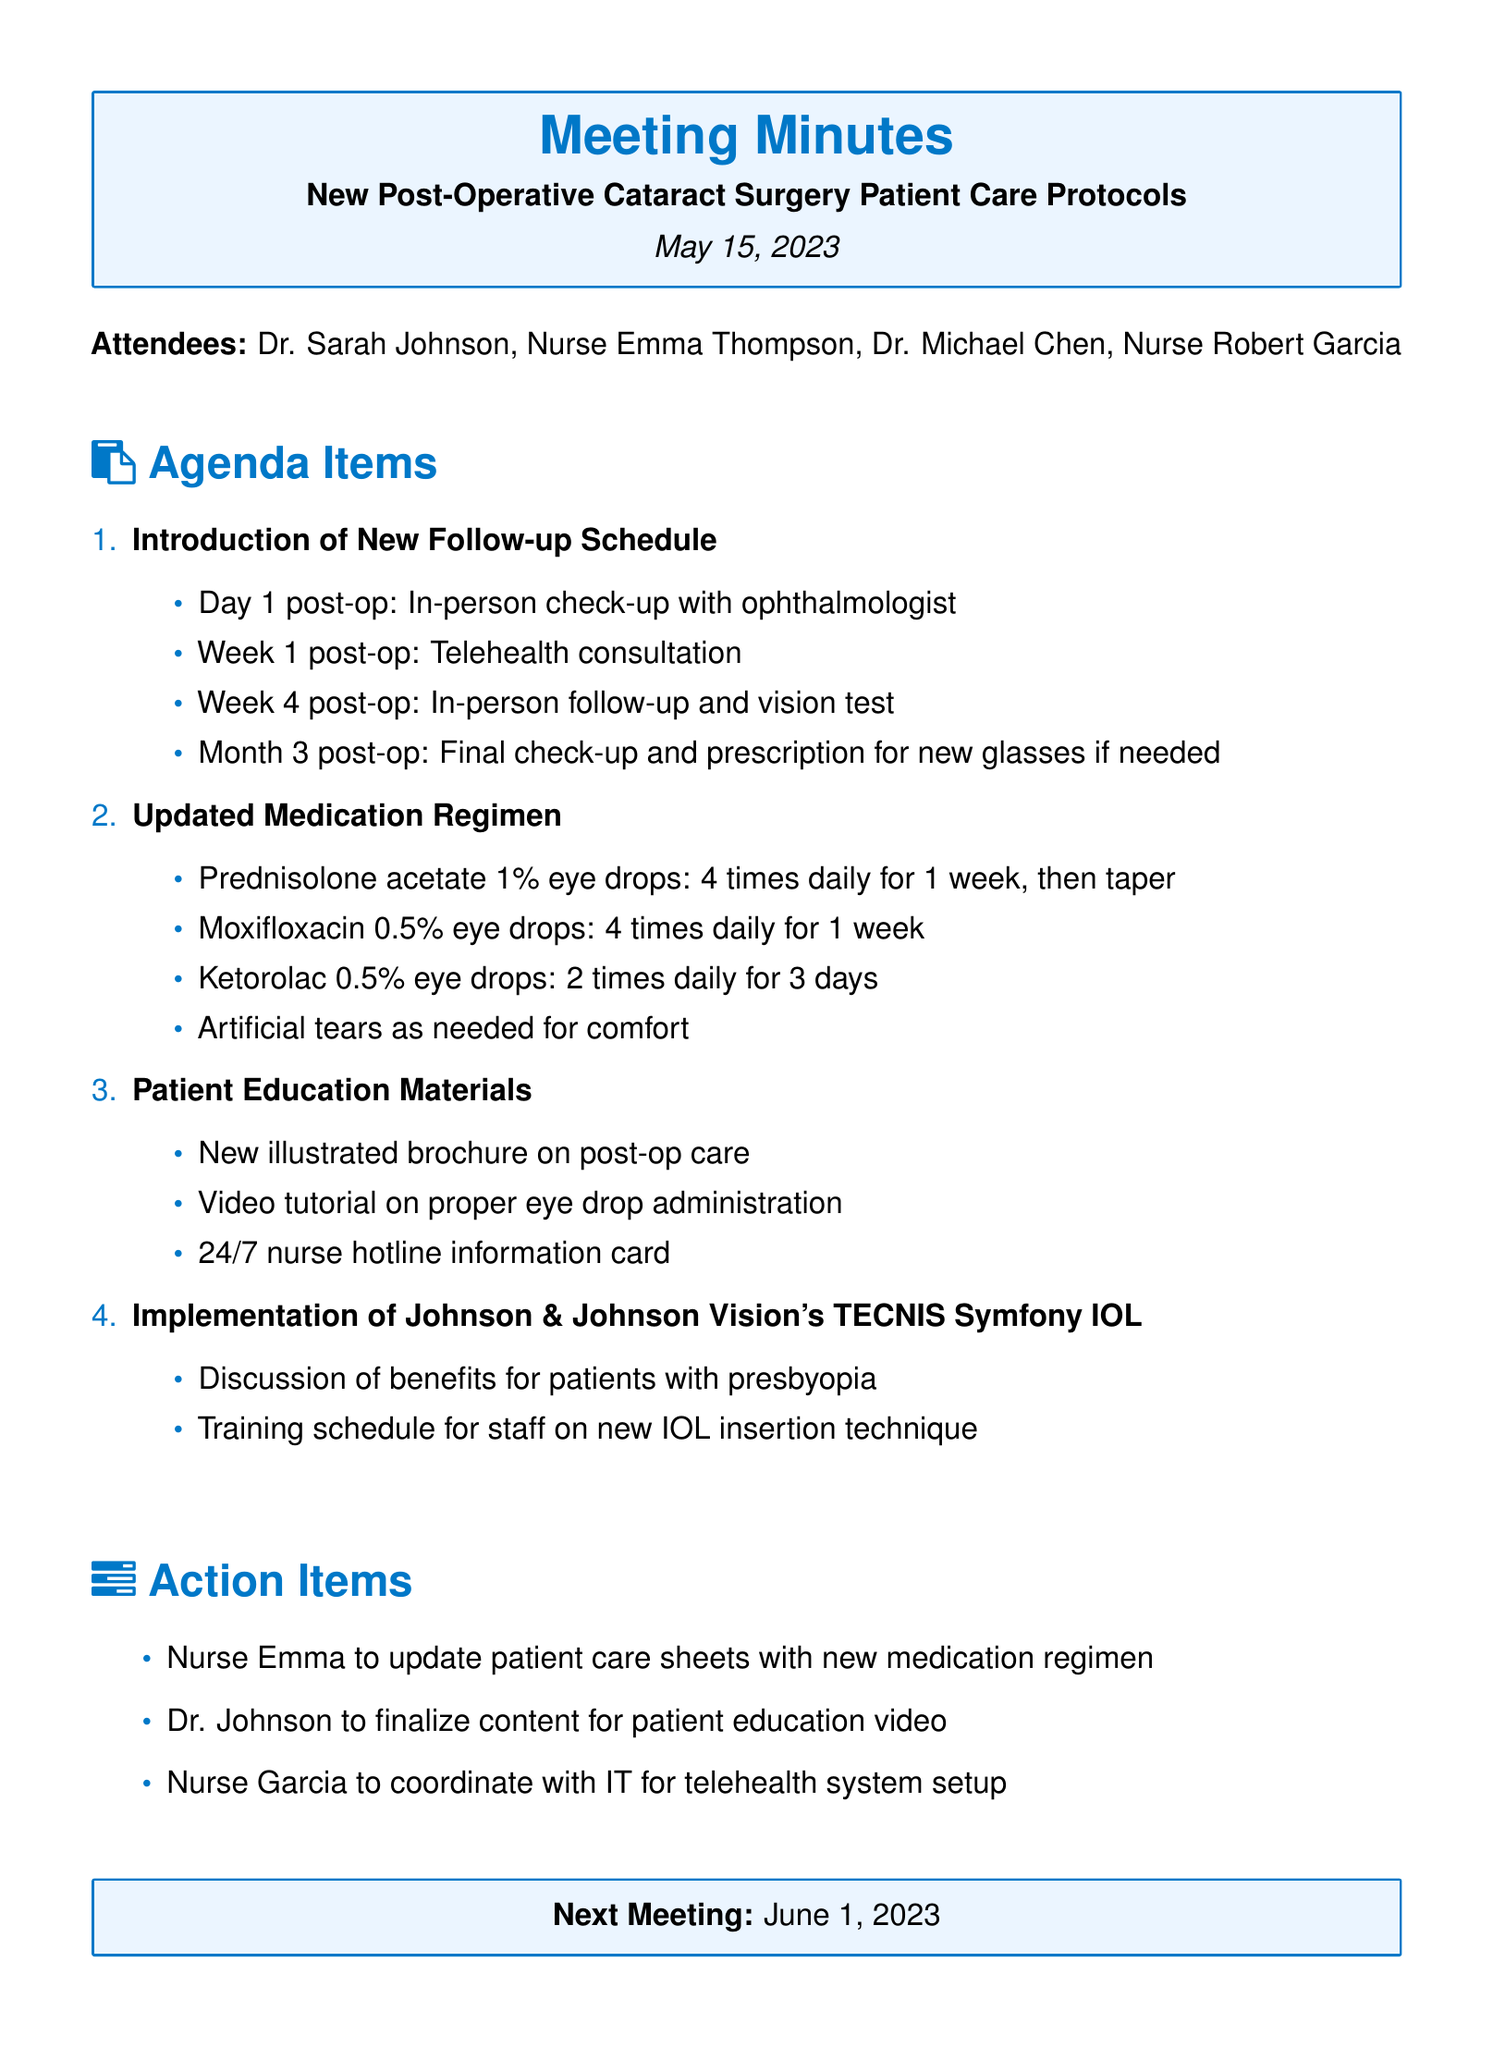What is the meeting title? The meeting title is stated at the beginning of the document.
Answer: New Post-Operative Cataract Surgery Patient Care Protocols What date was the meeting held? The date is listed just below the meeting title.
Answer: May 15, 2023 Who is the lead ophthalmologist? The lead ophthalmologist is mentioned in the list of attendees.
Answer: Dr. Sarah Johnson What is the follow-up schedule for Week 1 post-op? The follow-up schedule details are listed under the agenda items.
Answer: Telehealth consultation How often should Prednisolone acetate 1% eye drops be administered? The updated medication regimen specifies the frequency of eye drop administration.
Answer: 4 times daily for 1 week, then taper What is one of the new patient education materials? The patient education materials section lists several new resources.
Answer: New illustrated brochure on post-op care What is the next meeting date? The date of the next meeting is noted at the end of the document.
Answer: June 1, 2023 Who is responsible for updating patient care sheets? The action items detail responsibilities assigned to attendees.
Answer: Nurse Emma What is one benefit discussed regarding the TECNIS Symfony IOL? The agenda item regarding the TECNIS Symfony IOL mentions benefits discussed.
Answer: Benefits for patients with presbyopia 